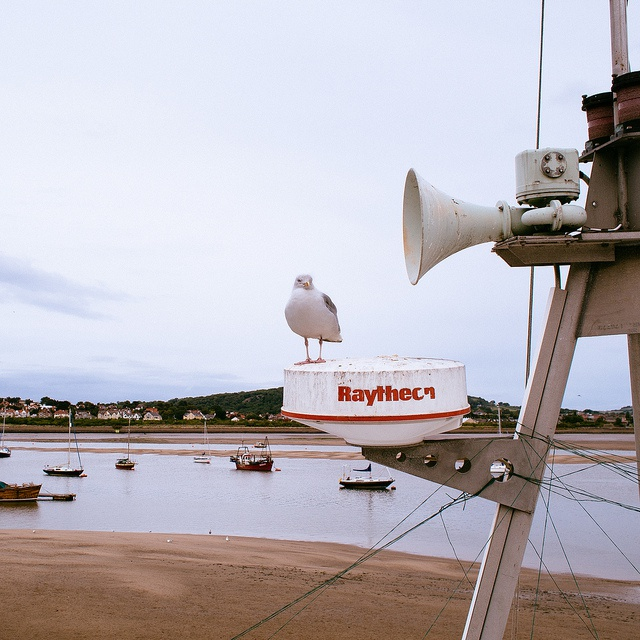Describe the objects in this image and their specific colors. I can see bird in lavender, darkgray, and gray tones, boat in lavender, black, maroon, and gray tones, boat in lavender, black, and darkgray tones, boat in lavender, black, darkgray, and gray tones, and boat in lavender, black, and maroon tones in this image. 